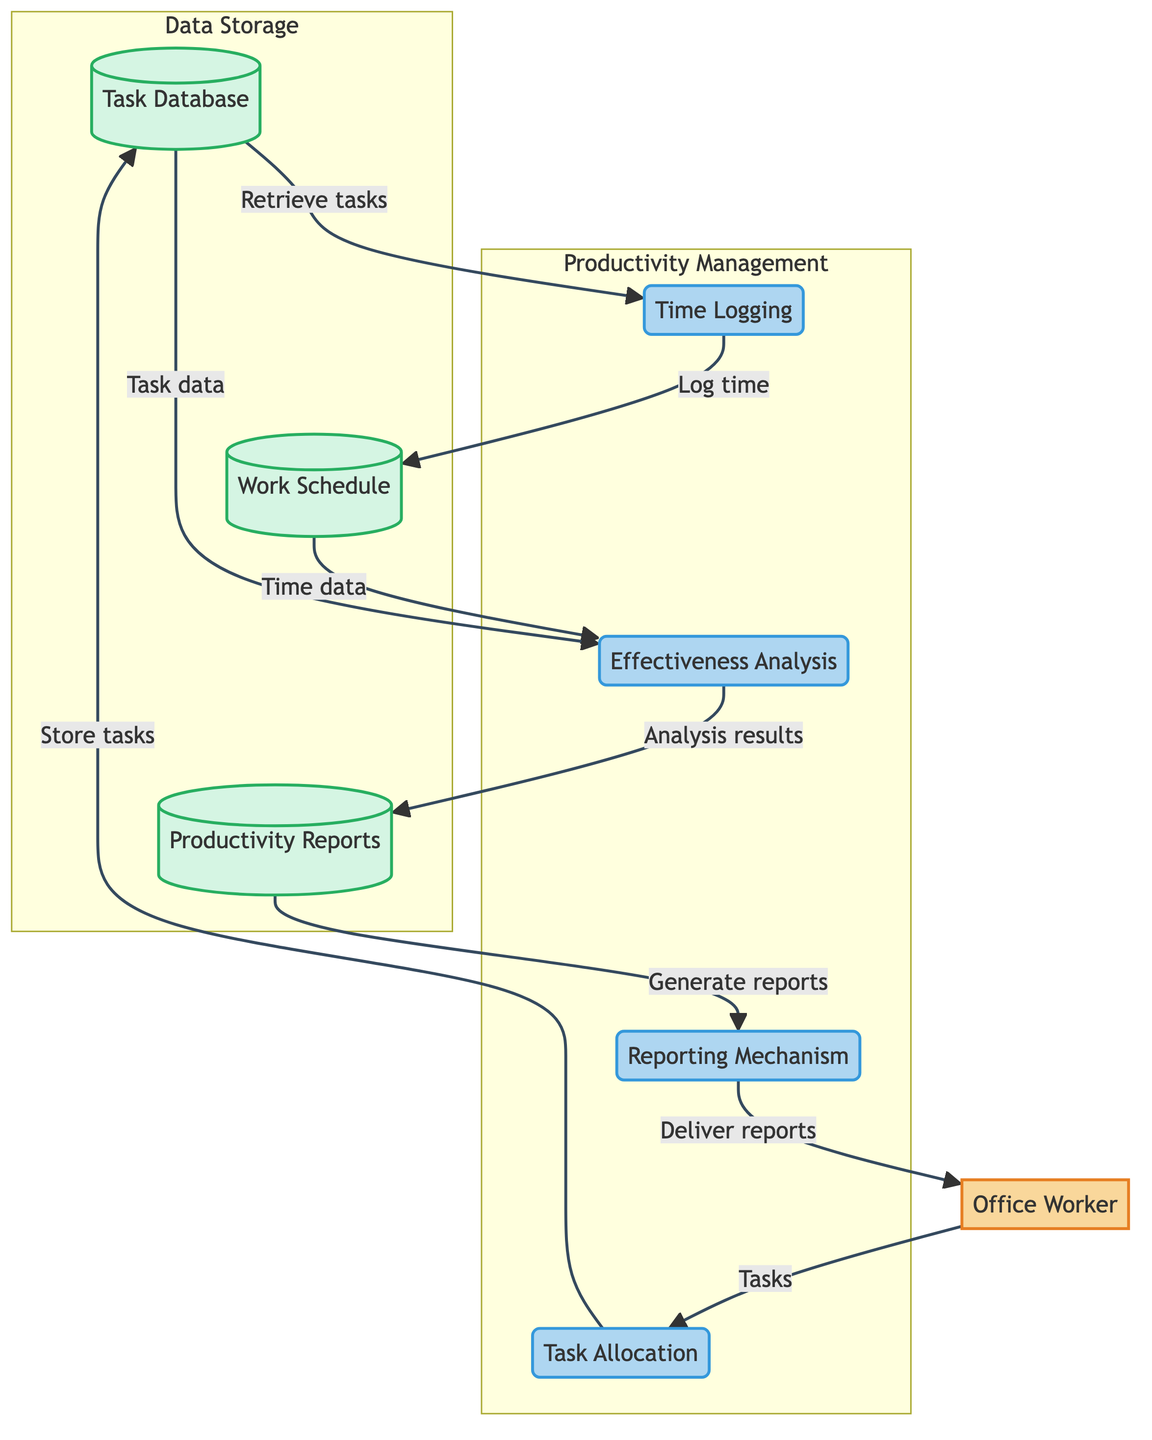What is the role of the Office Worker in this diagram? The diagram identifies the Office Worker as an external entity who interacts with the system, primarily handling specific tasks and projects while managing their workload.
Answer: External Entity How many main processes are illustrated in the diagram? By counting the processes labeled in the diagram, there are four distinct processes: Task Allocation, Time Logging, Effectiveness Analysis, and Reporting Mechanism.
Answer: Four What information does the Task Database store? The diagram specifies that the Task Database stores task details, deadlines, and priority levels for tasks allocated to the Office Worker.
Answer: Task details, deadlines, and priority levels What does the Office Worker receive from the Reporting Mechanism? The output from the Reporting Mechanism is directed to the Office Worker, identifying that the reports generated summarize task performance, time utilization, and suggestions for improvement.
Answer: Reports In which process does the Time Logging occur? The diagram explicitly depicts Time Logging as a process that records the time spent on each task. Hence, Time Logging is a standalone process itself within the system.
Answer: Time Logging How is time data used in the diagram? The time data logged from the Time Logging process is utilized in the Effectiveness Analysis process, where the overall productivity is evaluated based on time and task completions.
Answer: Evaluation of productivity Which data store is linked to both Task Database and Work Schedule? The diagram shows that both the Effectiveness Analysis process takes inputs from the Task Database and the Work Schedule, utilizing both data stores for productivity analysis.
Answer: Effectiveness Analysis What is the function of the Productivity Reports data store? According to the diagram, the Productivity Reports data store compiles the results from the Effectiveness Analysis process to generate and summarize reports.
Answer: Summarizes reports How does the Task Allocation process interact with the Office Worker? The diagram illustrates that the Task Allocation process interacts with the Office Worker by assigning tasks based on project requirements and the employee's current workload.
Answer: Assigns tasks 